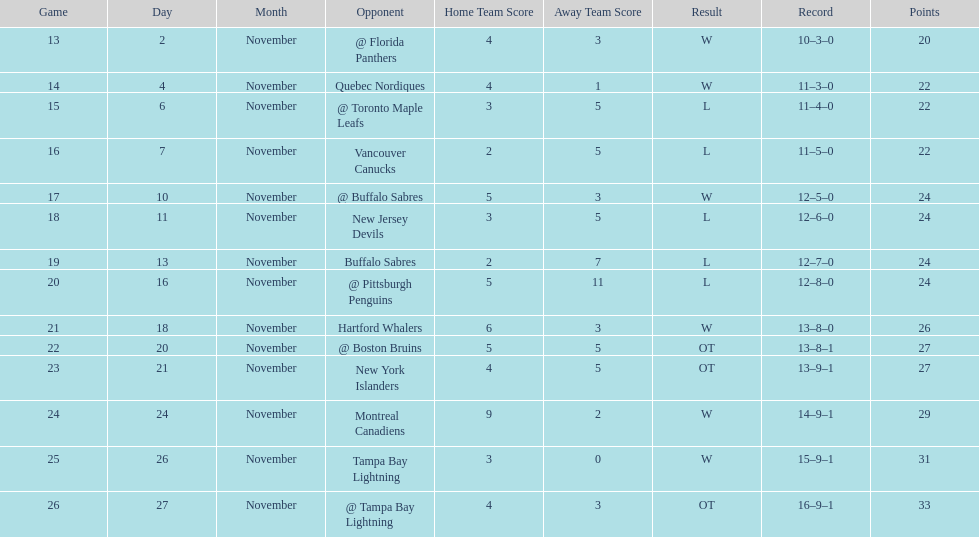What was the number of wins the philadelphia flyers had? 35. 